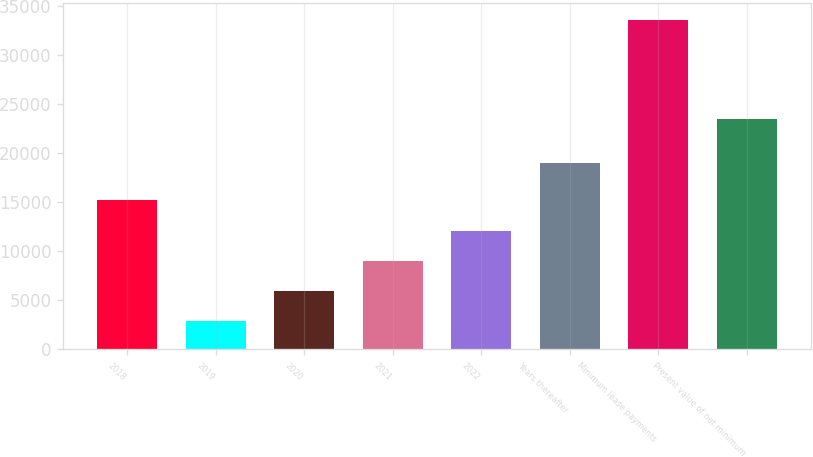Convert chart. <chart><loc_0><loc_0><loc_500><loc_500><bar_chart><fcel>2018<fcel>2019<fcel>2020<fcel>2021<fcel>2022<fcel>Years thereafter<fcel>Minimum lease payments<fcel>Present value of net minimum<nl><fcel>15160.2<fcel>2887<fcel>5955.3<fcel>9023.6<fcel>12091.9<fcel>19004<fcel>33570<fcel>23519<nl></chart> 